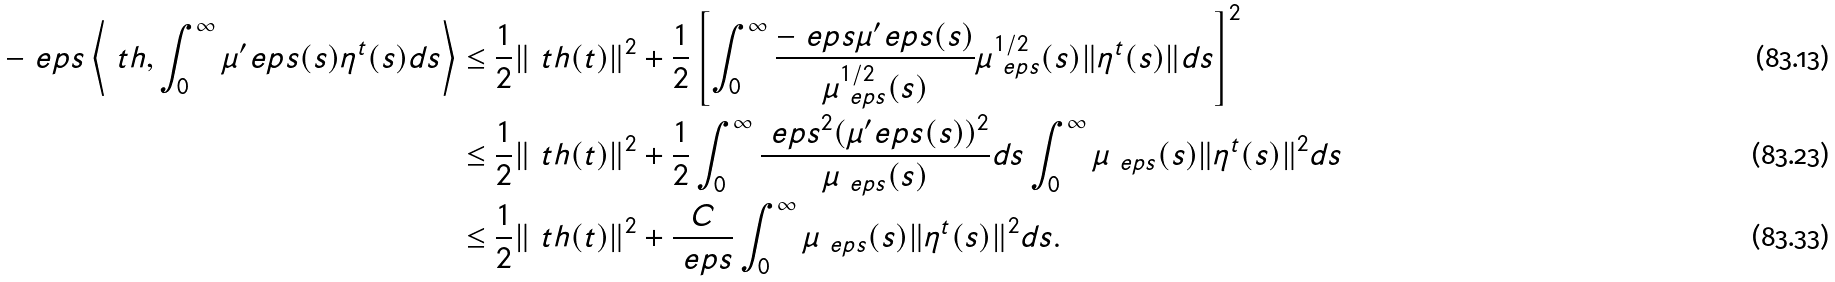<formula> <loc_0><loc_0><loc_500><loc_500>- \ e p s \left \langle \ t h , \int _ { 0 } ^ { \infty } \mu ^ { \prime } _ { \ } e p s ( s ) \eta ^ { t } ( s ) d s \right \rangle & \leq \frac { 1 } { 2 } \| \ t h ( t ) \| ^ { 2 } + \frac { 1 } { 2 } \left [ \int _ { 0 } ^ { \infty } \frac { - \ e p s \mu ^ { \prime } _ { \ } e p s ( s ) } { \mu _ { \ e p s } ^ { 1 / 2 } ( s ) } \mu _ { \ e p s } ^ { 1 / 2 } ( s ) \| \eta ^ { t } ( s ) \| d s \right ] ^ { 2 } \\ & \leq \frac { 1 } { 2 } \| \ t h ( t ) \| ^ { 2 } + \frac { 1 } { 2 } \int _ { 0 } ^ { \infty } \frac { \ e p s ^ { 2 } ( \mu ^ { \prime } _ { \ } e p s ( s ) ) ^ { 2 } } { \mu _ { \ e p s } ( s ) } d s \int _ { 0 } ^ { \infty } \mu _ { \ e p s } ( s ) \| \eta ^ { t } ( s ) \| ^ { 2 } d s \\ & \leq \frac { 1 } { 2 } \| \ t h ( t ) \| ^ { 2 } + \frac { C } { \ e p s } \int _ { 0 } ^ { \infty } \mu _ { \ e p s } ( s ) \| \eta ^ { t } ( s ) \| ^ { 2 } d s .</formula> 